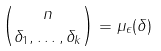<formula> <loc_0><loc_0><loc_500><loc_500>\binom { n } { \delta _ { 1 } , \dots , \delta _ { k } } = \mu _ { \epsilon } ( \delta )</formula> 